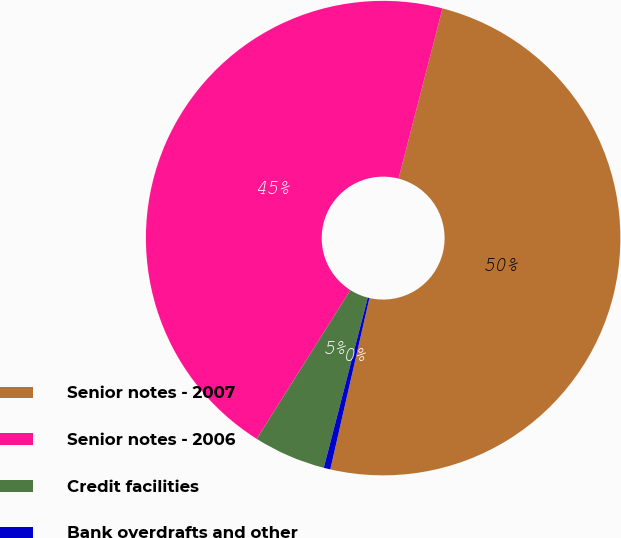<chart> <loc_0><loc_0><loc_500><loc_500><pie_chart><fcel>Senior notes - 2007<fcel>Senior notes - 2006<fcel>Credit facilities<fcel>Bank overdrafts and other<nl><fcel>49.55%<fcel>45.08%<fcel>4.92%<fcel>0.45%<nl></chart> 